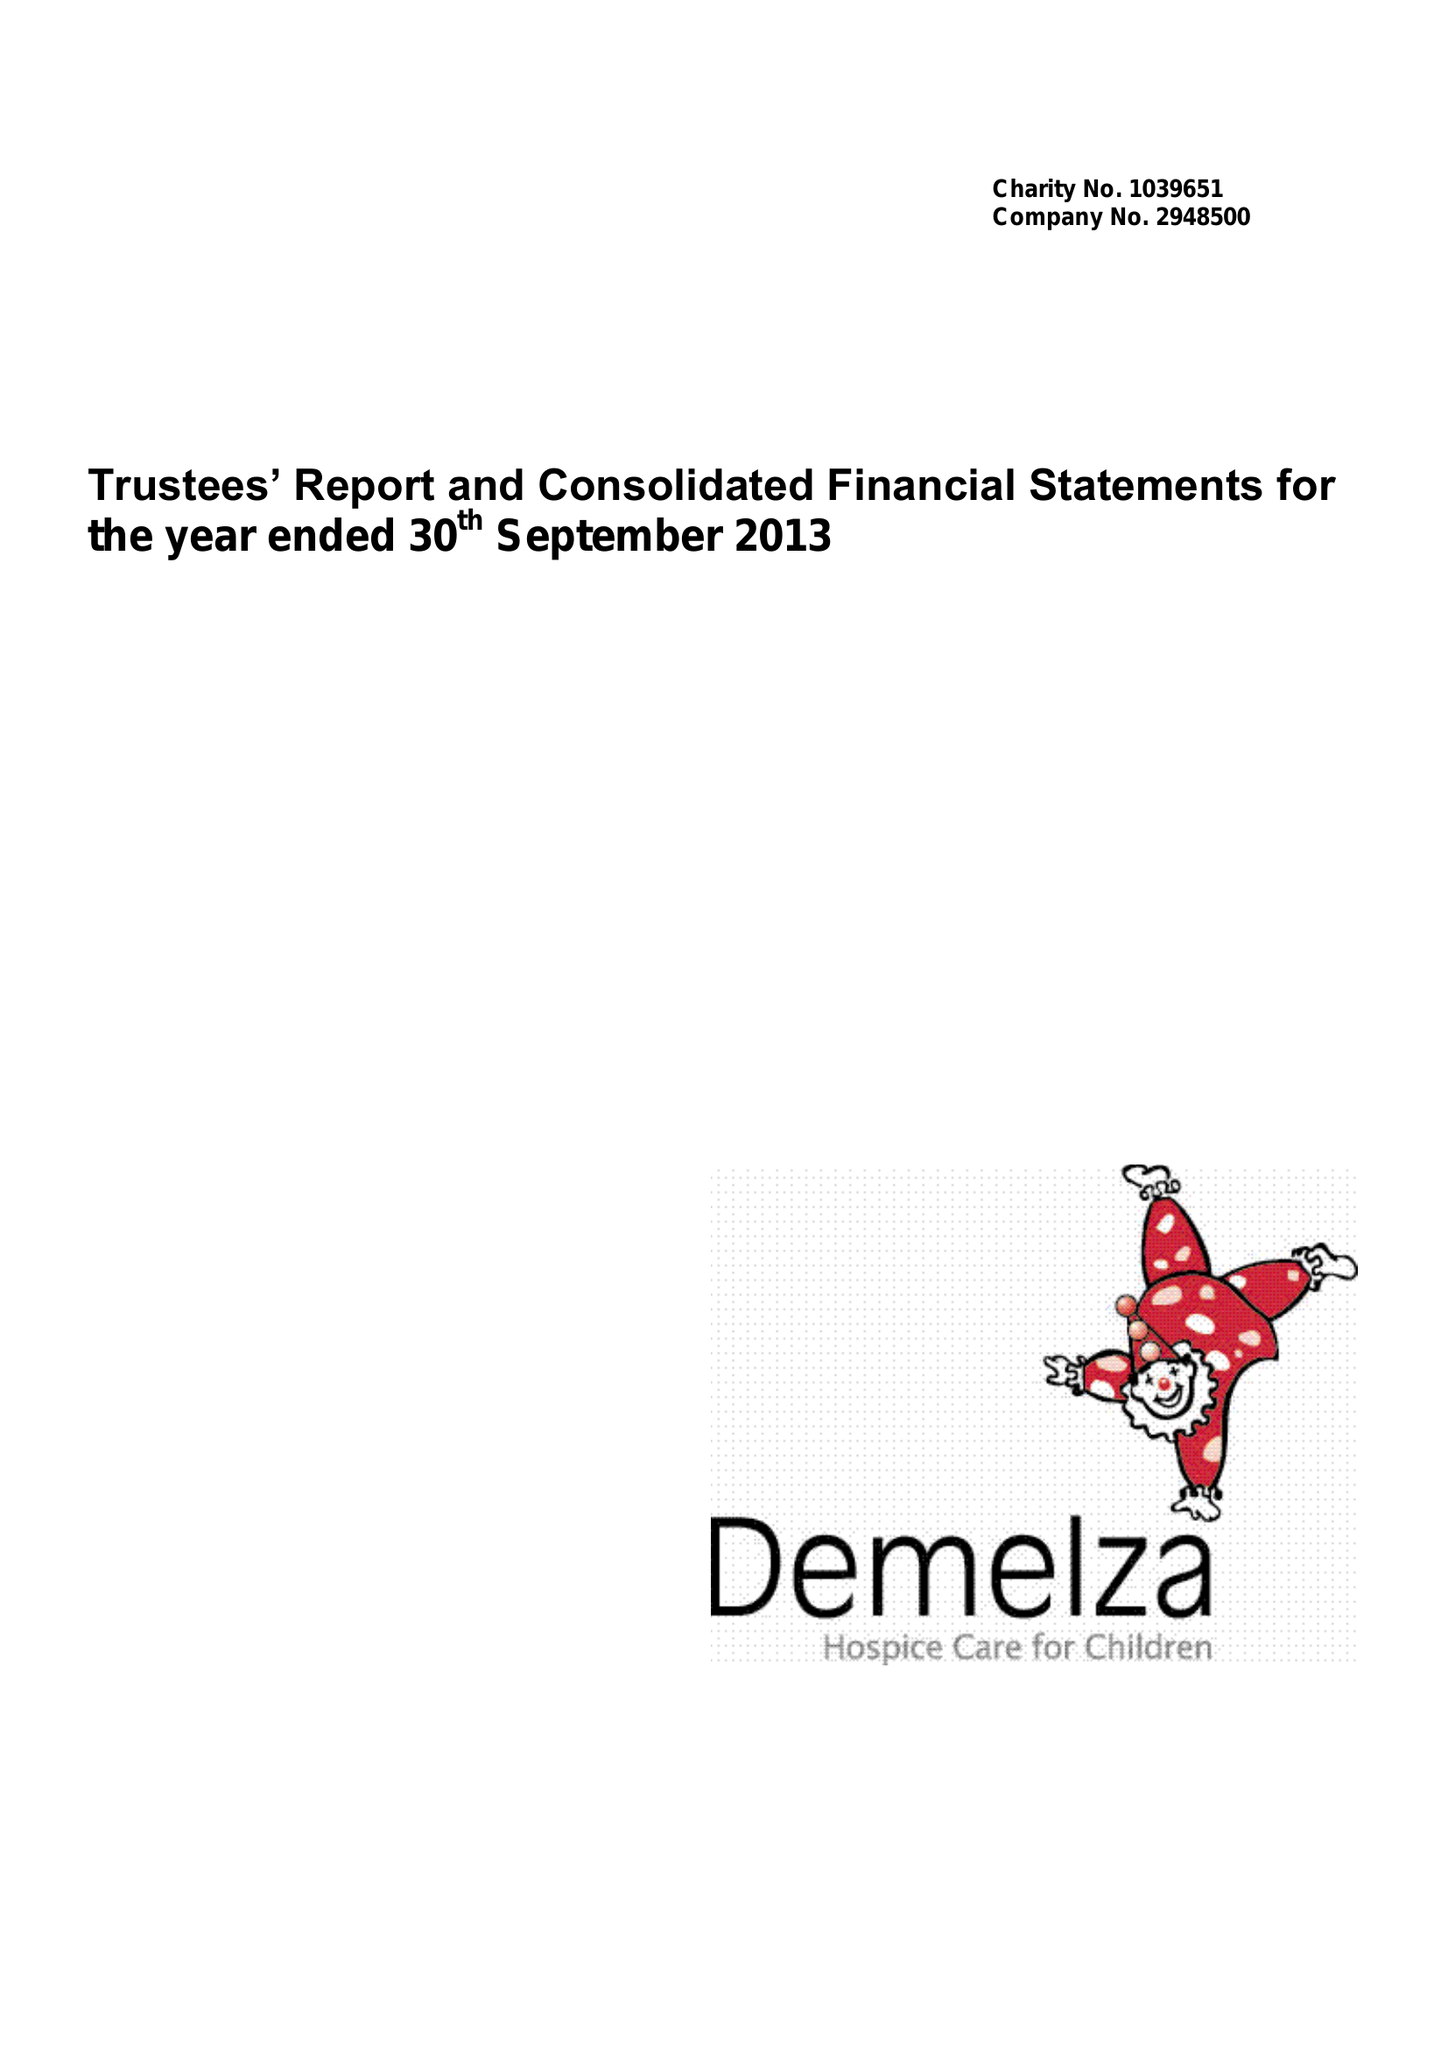What is the value for the address__street_line?
Answer the question using a single word or phrase. ROOK LANE 